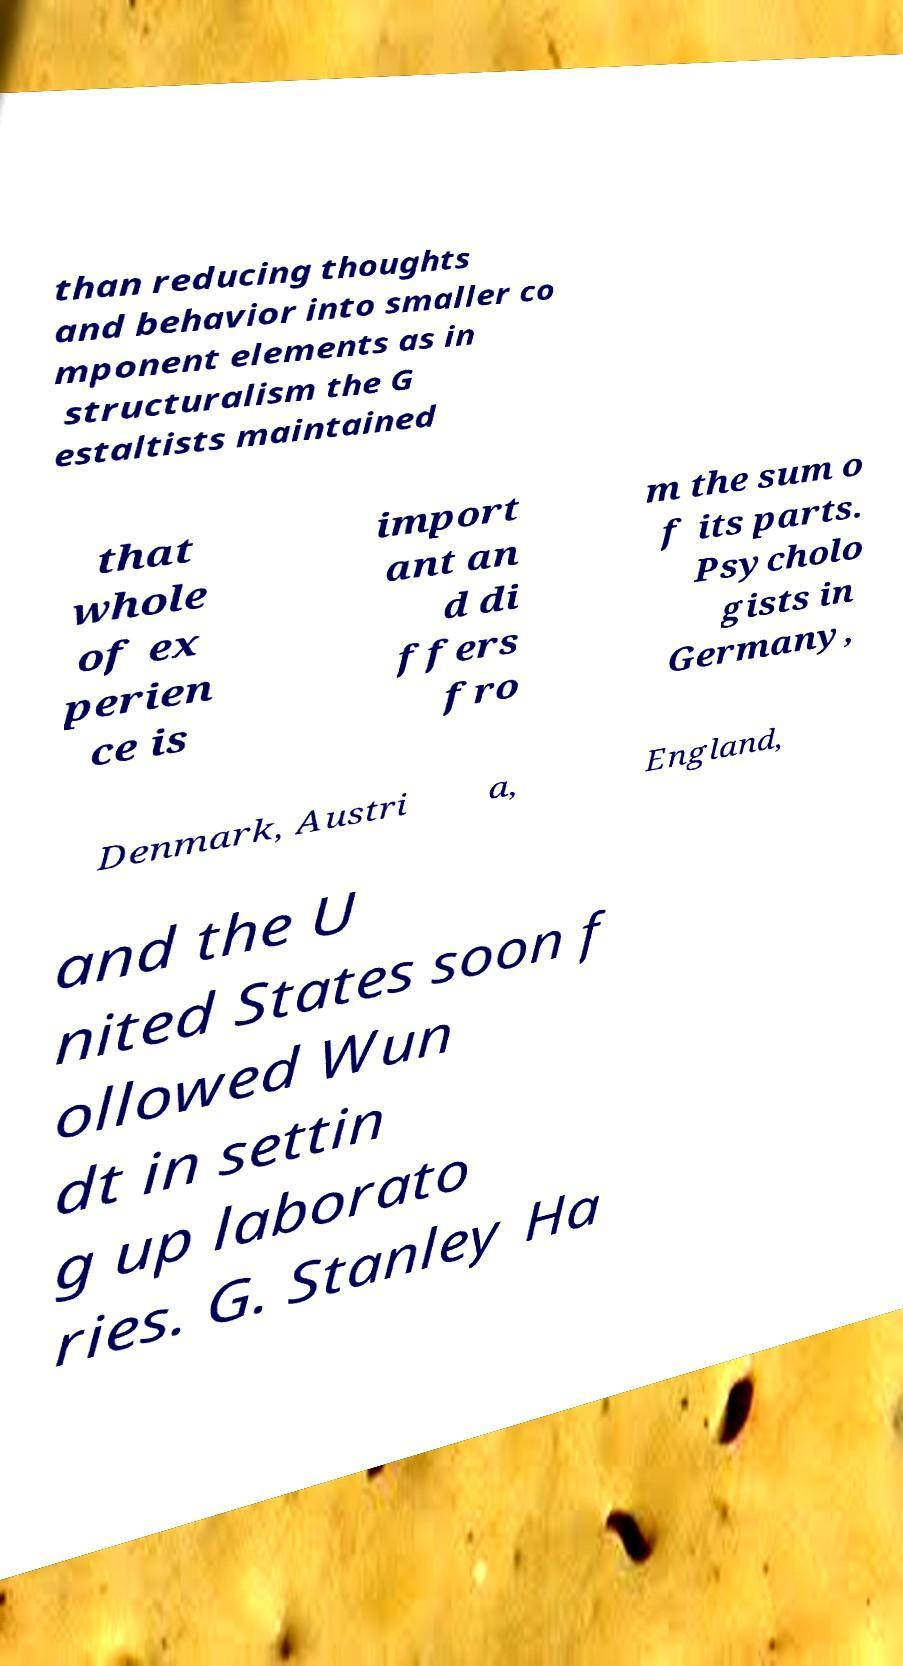Could you assist in decoding the text presented in this image and type it out clearly? than reducing thoughts and behavior into smaller co mponent elements as in structuralism the G estaltists maintained that whole of ex perien ce is import ant an d di ffers fro m the sum o f its parts. Psycholo gists in Germany, Denmark, Austri a, England, and the U nited States soon f ollowed Wun dt in settin g up laborato ries. G. Stanley Ha 